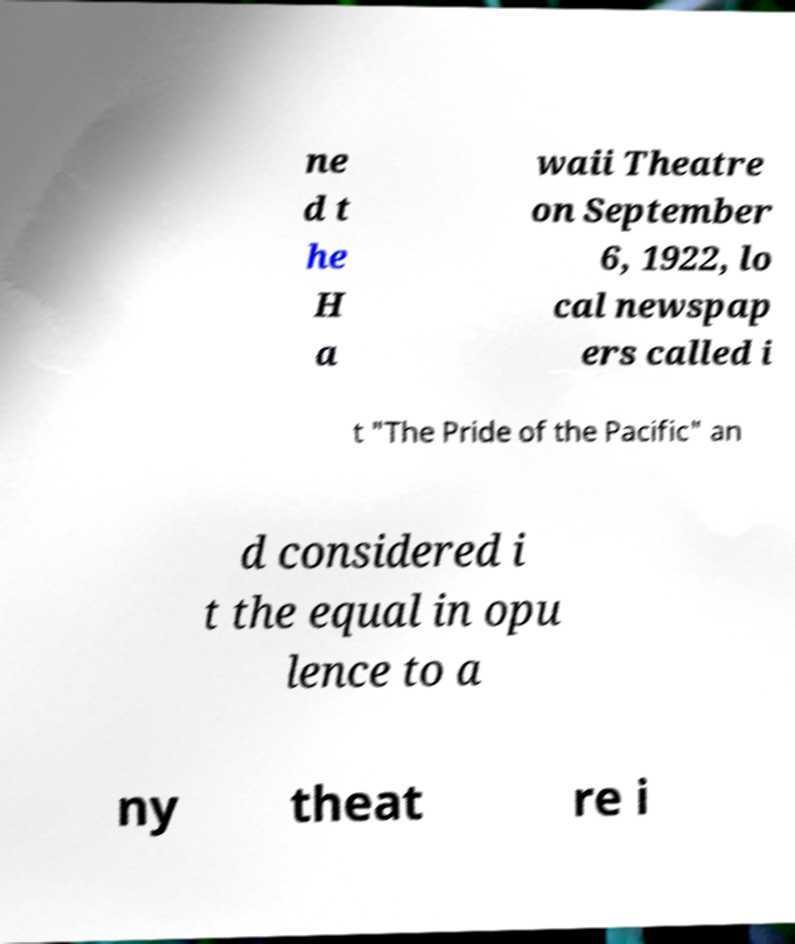Can you read and provide the text displayed in the image?This photo seems to have some interesting text. Can you extract and type it out for me? ne d t he H a waii Theatre on September 6, 1922, lo cal newspap ers called i t "The Pride of the Pacific" an d considered i t the equal in opu lence to a ny theat re i 